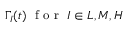Convert formula to latex. <formula><loc_0><loc_0><loc_500><loc_500>\Gamma _ { I } ( t ) \, f o r \, I \in { L , M , H }</formula> 